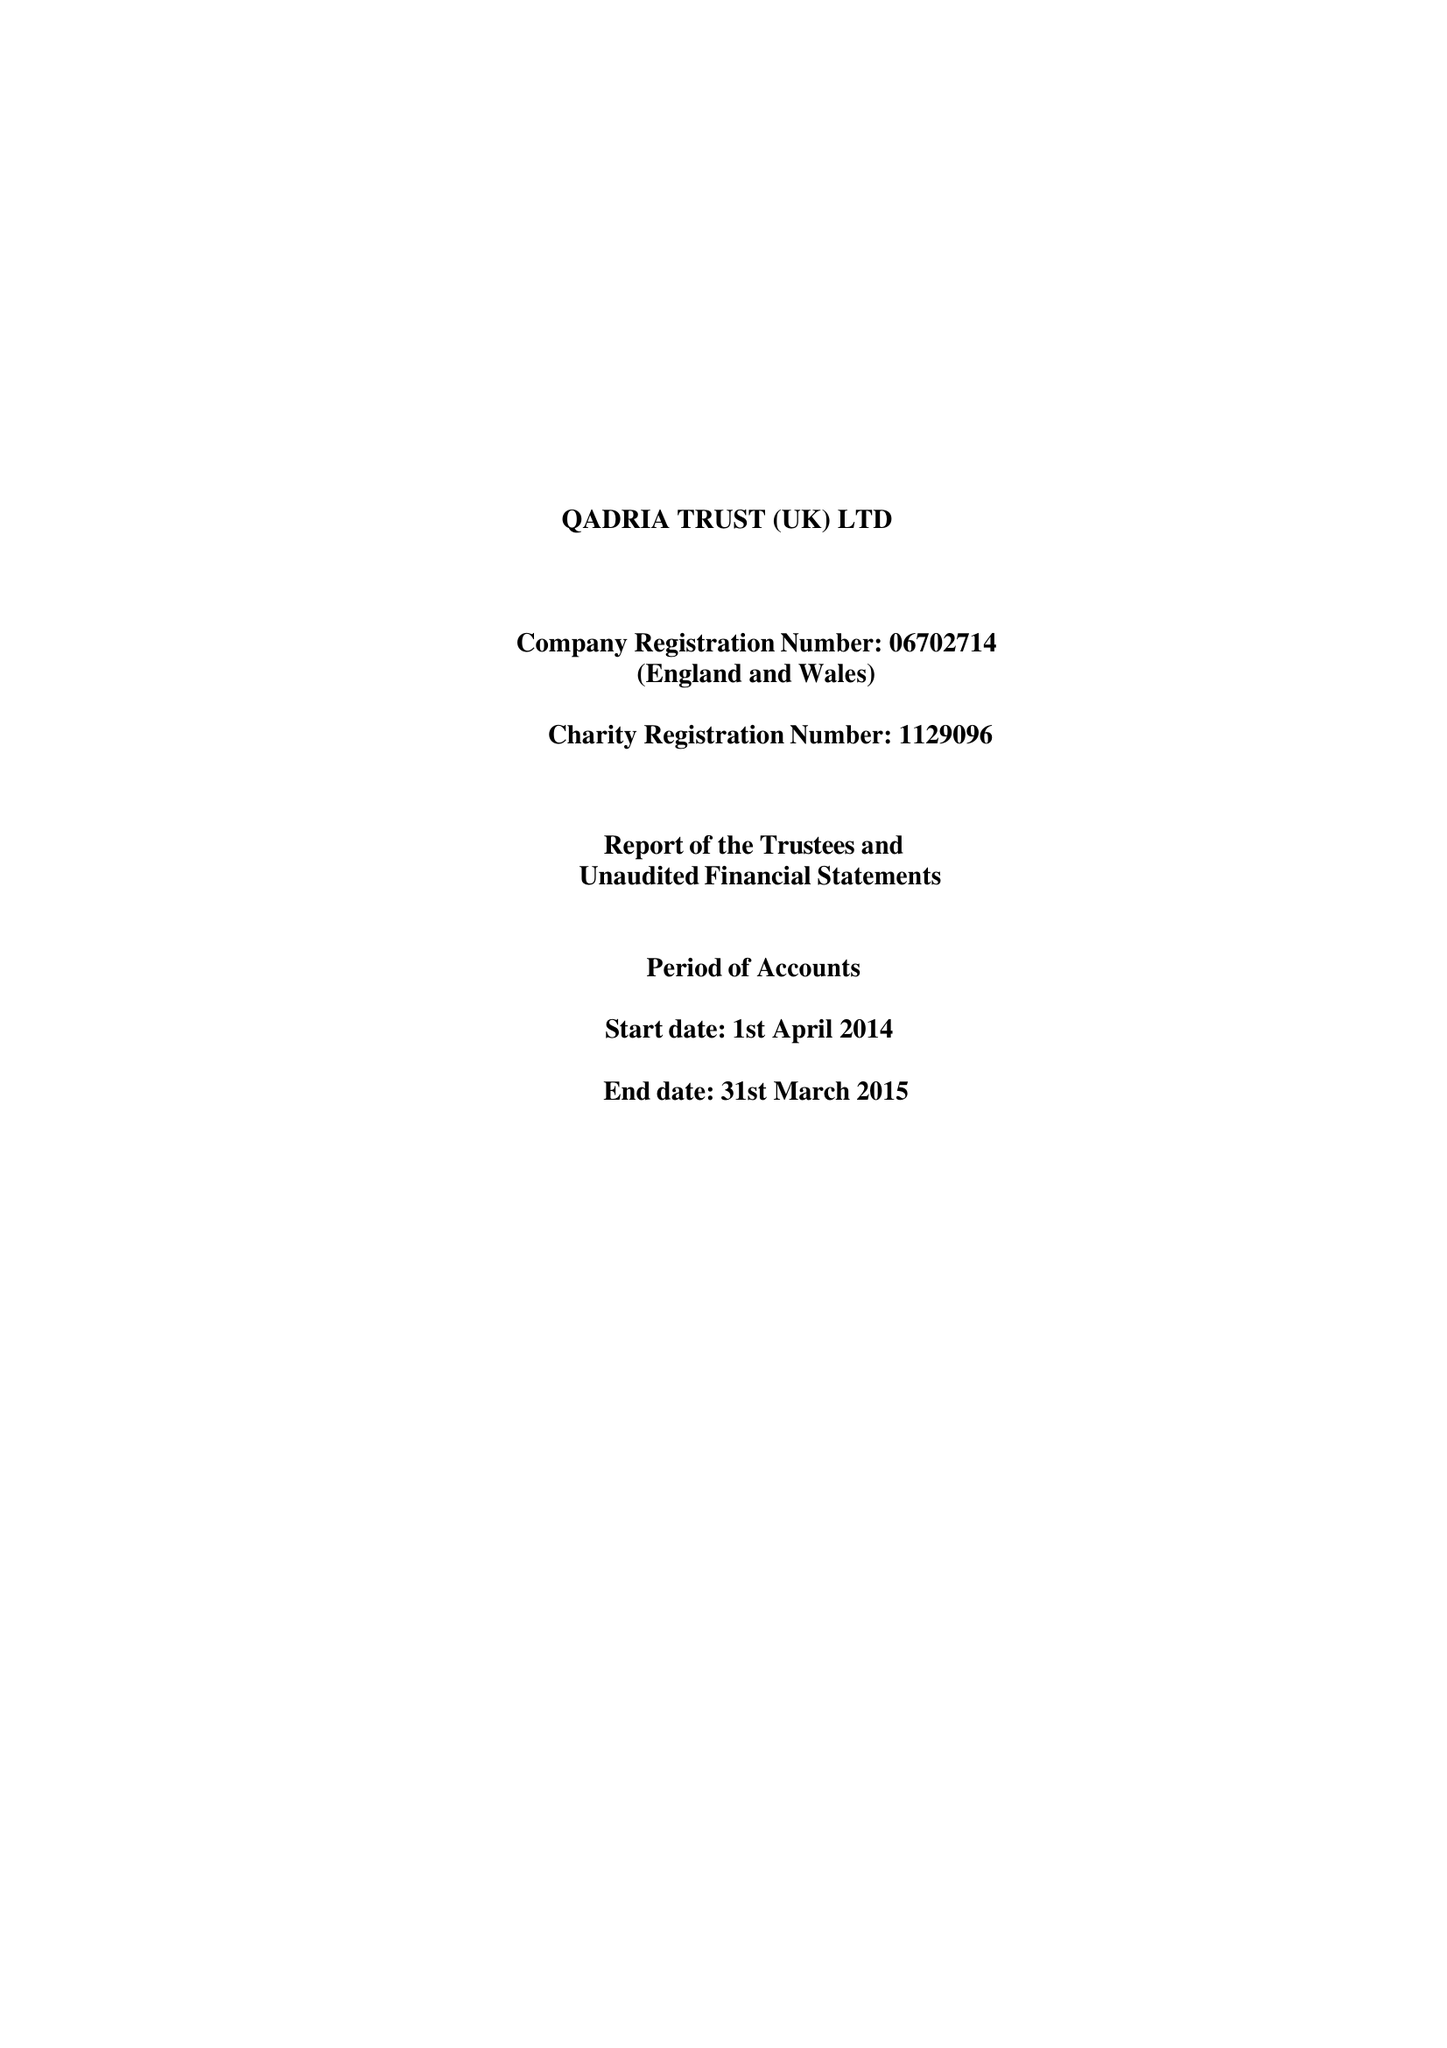What is the value for the address__postcode?
Answer the question using a single word or phrase. B12 8JL 